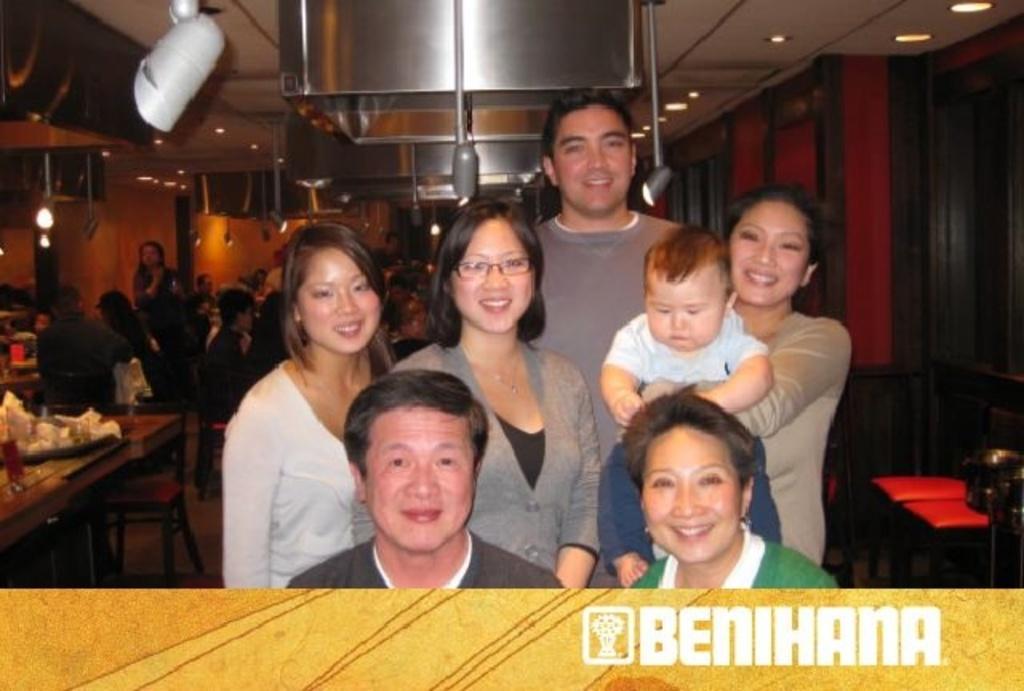In one or two sentences, can you explain what this image depicts? There are few persons and they are smiling. In the background we can see tables, chairs, lights, wall, screen, and persons. 